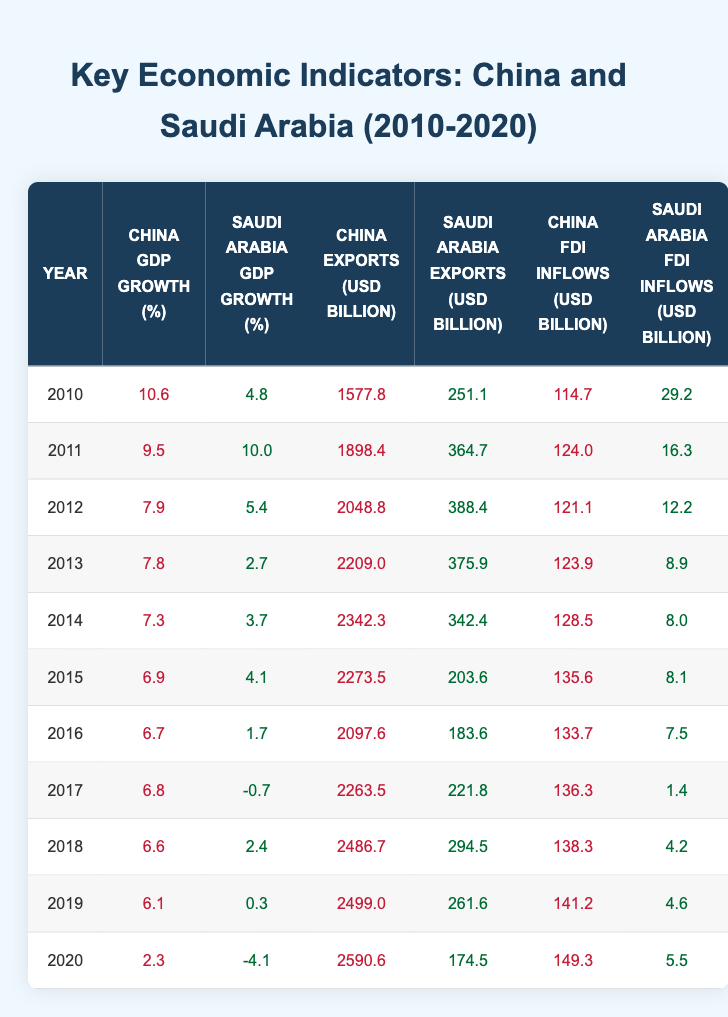What was China's GDP growth in 2015? In 2015, the table shows that China's GDP growth was 6.9% as indicated in the respective column for that year.
Answer: 6.9% What was the total export value of Saudi Arabia in 2012? Referring to 2012, Saudi Arabia's exports were 388.4 billion USD. This is the total export value for that year.
Answer: 388.4 billion USD Did Saudi Arabia experience negative GDP growth in 2017? In 2017, the table indicates that Saudi Arabia's GDP growth was -0.7%, which confirms that there was indeed negative growth that year.
Answer: Yes Which year had the highest FDI inflows in Saudi Arabia? Looking through the FDI inflows data for Saudi Arabia from 2010 to 2020, the highest inflow was in 2011, with 16.3 billion USD.
Answer: 2011 What is the average GDP growth rate for China from 2010 to 2019? To find the average, we sum the GDP growth rates from 2010 to 2019: (10.6 + 9.5 + 7.9 + 7.8 + 7.3 + 6.9 + 6.7 + 6.8 + 6.1) = 69.6. Then divide by the number of years (10): 69.6 / 10 = 6.96%.
Answer: 6.96% In which year did China have exports exceeding 2000 billion USD? Referring to the exports column for China, the years with exports exceeding 2000 billion USD were 2012 (2048.8), 2013 (2209.0), 2014 (2342.3), 2015 (2273.5), 2016 (2097.6), 2017 (2263.5), 2018 (2486.7), 2019 (2499.0), and 2020 (2590.6). The first year that crossed this threshold is 2012.
Answer: 2012 Calculate the difference in FDI inflows between China and Saudi Arabia in 2020. In 2020, China's FDI inflows were 149.3 billion USD and Saudi Arabia's were 5.5 billion USD. The difference is calculated as 149.3 - 5.5 = 143.8 billion USD.
Answer: 143.8 billion USD Were China's exports greater than Saudi Arabia's exports every year from 2010 to 2020? By comparing the annual export values for both countries from 2010 to 2020, we find that China's exports consistently exceeded Saudi Arabia's exports each year.
Answer: Yes What was the trend of Saudi Arabia's GDP growth from 2011 to 2020? Analyzing the table, we see that Saudi Arabia's GDP growth peaked at 10.0% in 2011, then fluctuated and descended to -4.1% by 2020. Overall, the trend shows a decline over the years, alternating between positive and negative growth.
Answer: Decline 